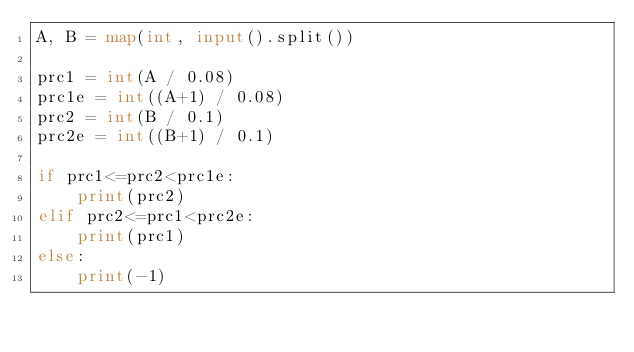<code> <loc_0><loc_0><loc_500><loc_500><_Python_>A, B = map(int, input().split())

prc1 = int(A / 0.08)
prc1e = int((A+1) / 0.08)
prc2 = int(B / 0.1)
prc2e = int((B+1) / 0.1)

if prc1<=prc2<prc1e:
    print(prc2)
elif prc2<=prc1<prc2e:
    print(prc1)
else:
    print(-1)
</code> 